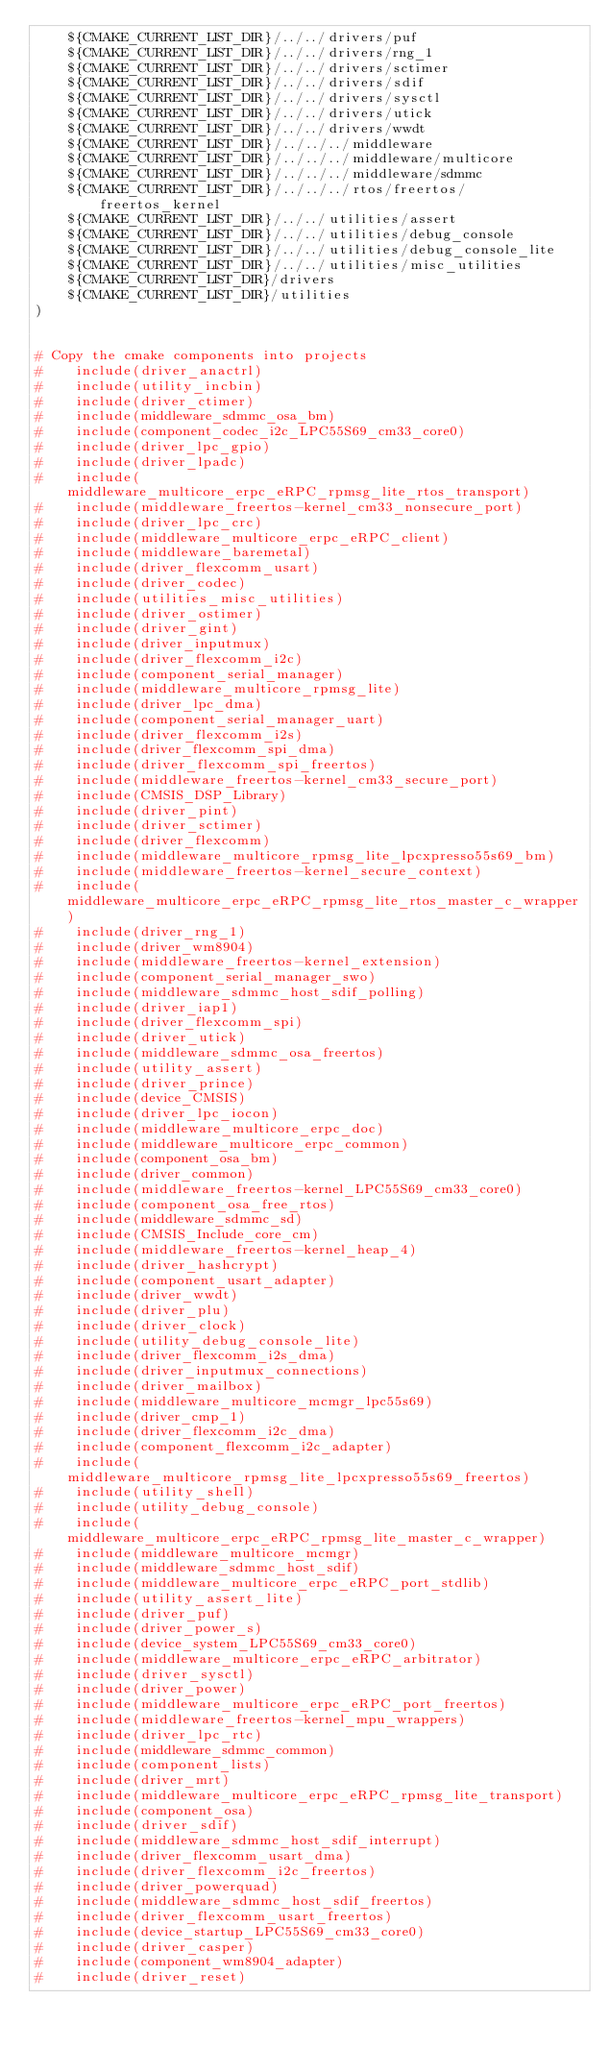Convert code to text. <code><loc_0><loc_0><loc_500><loc_500><_CMake_>    ${CMAKE_CURRENT_LIST_DIR}/../../drivers/puf
    ${CMAKE_CURRENT_LIST_DIR}/../../drivers/rng_1
    ${CMAKE_CURRENT_LIST_DIR}/../../drivers/sctimer
    ${CMAKE_CURRENT_LIST_DIR}/../../drivers/sdif
    ${CMAKE_CURRENT_LIST_DIR}/../../drivers/sysctl
    ${CMAKE_CURRENT_LIST_DIR}/../../drivers/utick
    ${CMAKE_CURRENT_LIST_DIR}/../../drivers/wwdt
    ${CMAKE_CURRENT_LIST_DIR}/../../../middleware
    ${CMAKE_CURRENT_LIST_DIR}/../../../middleware/multicore
    ${CMAKE_CURRENT_LIST_DIR}/../../../middleware/sdmmc
    ${CMAKE_CURRENT_LIST_DIR}/../../../rtos/freertos/freertos_kernel
    ${CMAKE_CURRENT_LIST_DIR}/../../utilities/assert
    ${CMAKE_CURRENT_LIST_DIR}/../../utilities/debug_console
    ${CMAKE_CURRENT_LIST_DIR}/../../utilities/debug_console_lite
    ${CMAKE_CURRENT_LIST_DIR}/../../utilities/misc_utilities
    ${CMAKE_CURRENT_LIST_DIR}/drivers
    ${CMAKE_CURRENT_LIST_DIR}/utilities
)


# Copy the cmake components into projects
#    include(driver_anactrl)
#    include(utility_incbin)
#    include(driver_ctimer)
#    include(middleware_sdmmc_osa_bm)
#    include(component_codec_i2c_LPC55S69_cm33_core0)
#    include(driver_lpc_gpio)
#    include(driver_lpadc)
#    include(middleware_multicore_erpc_eRPC_rpmsg_lite_rtos_transport)
#    include(middleware_freertos-kernel_cm33_nonsecure_port)
#    include(driver_lpc_crc)
#    include(middleware_multicore_erpc_eRPC_client)
#    include(middleware_baremetal)
#    include(driver_flexcomm_usart)
#    include(driver_codec)
#    include(utilities_misc_utilities)
#    include(driver_ostimer)
#    include(driver_gint)
#    include(driver_inputmux)
#    include(driver_flexcomm_i2c)
#    include(component_serial_manager)
#    include(middleware_multicore_rpmsg_lite)
#    include(driver_lpc_dma)
#    include(component_serial_manager_uart)
#    include(driver_flexcomm_i2s)
#    include(driver_flexcomm_spi_dma)
#    include(driver_flexcomm_spi_freertos)
#    include(middleware_freertos-kernel_cm33_secure_port)
#    include(CMSIS_DSP_Library)
#    include(driver_pint)
#    include(driver_sctimer)
#    include(driver_flexcomm)
#    include(middleware_multicore_rpmsg_lite_lpcxpresso55s69_bm)
#    include(middleware_freertos-kernel_secure_context)
#    include(middleware_multicore_erpc_eRPC_rpmsg_lite_rtos_master_c_wrapper)
#    include(driver_rng_1)
#    include(driver_wm8904)
#    include(middleware_freertos-kernel_extension)
#    include(component_serial_manager_swo)
#    include(middleware_sdmmc_host_sdif_polling)
#    include(driver_iap1)
#    include(driver_flexcomm_spi)
#    include(driver_utick)
#    include(middleware_sdmmc_osa_freertos)
#    include(utility_assert)
#    include(driver_prince)
#    include(device_CMSIS)
#    include(driver_lpc_iocon)
#    include(middleware_multicore_erpc_doc)
#    include(middleware_multicore_erpc_common)
#    include(component_osa_bm)
#    include(driver_common)
#    include(middleware_freertos-kernel_LPC55S69_cm33_core0)
#    include(component_osa_free_rtos)
#    include(middleware_sdmmc_sd)
#    include(CMSIS_Include_core_cm)
#    include(middleware_freertos-kernel_heap_4)
#    include(driver_hashcrypt)
#    include(component_usart_adapter)
#    include(driver_wwdt)
#    include(driver_plu)
#    include(driver_clock)
#    include(utility_debug_console_lite)
#    include(driver_flexcomm_i2s_dma)
#    include(driver_inputmux_connections)
#    include(driver_mailbox)
#    include(middleware_multicore_mcmgr_lpc55s69)
#    include(driver_cmp_1)
#    include(driver_flexcomm_i2c_dma)
#    include(component_flexcomm_i2c_adapter)
#    include(middleware_multicore_rpmsg_lite_lpcxpresso55s69_freertos)
#    include(utility_shell)
#    include(utility_debug_console)
#    include(middleware_multicore_erpc_eRPC_rpmsg_lite_master_c_wrapper)
#    include(middleware_multicore_mcmgr)
#    include(middleware_sdmmc_host_sdif)
#    include(middleware_multicore_erpc_eRPC_port_stdlib)
#    include(utility_assert_lite)
#    include(driver_puf)
#    include(driver_power_s)
#    include(device_system_LPC55S69_cm33_core0)
#    include(middleware_multicore_erpc_eRPC_arbitrator)
#    include(driver_sysctl)
#    include(driver_power)
#    include(middleware_multicore_erpc_eRPC_port_freertos)
#    include(middleware_freertos-kernel_mpu_wrappers)
#    include(driver_lpc_rtc)
#    include(middleware_sdmmc_common)
#    include(component_lists)
#    include(driver_mrt)
#    include(middleware_multicore_erpc_eRPC_rpmsg_lite_transport)
#    include(component_osa)
#    include(driver_sdif)
#    include(middleware_sdmmc_host_sdif_interrupt)
#    include(driver_flexcomm_usart_dma)
#    include(driver_flexcomm_i2c_freertos)
#    include(driver_powerquad)
#    include(middleware_sdmmc_host_sdif_freertos)
#    include(driver_flexcomm_usart_freertos)
#    include(device_startup_LPC55S69_cm33_core0)
#    include(driver_casper)
#    include(component_wm8904_adapter)
#    include(driver_reset)
</code> 